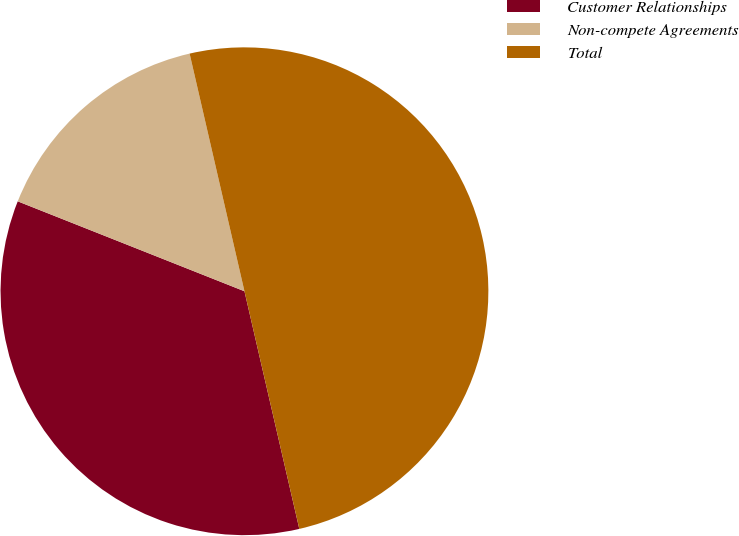<chart> <loc_0><loc_0><loc_500><loc_500><pie_chart><fcel>Customer Relationships<fcel>Non-compete Agreements<fcel>Total<nl><fcel>34.62%<fcel>15.38%<fcel>50.0%<nl></chart> 